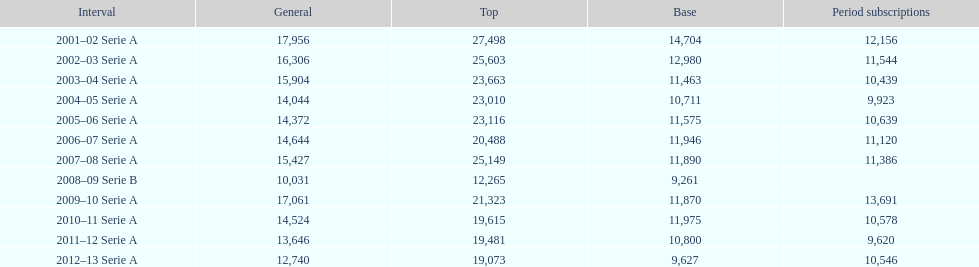What was the average attendance in 2008? 10,031. 